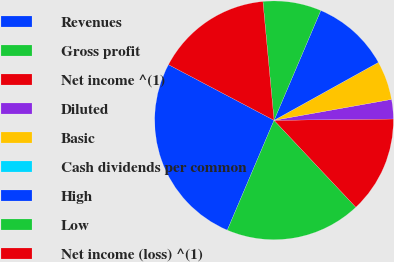<chart> <loc_0><loc_0><loc_500><loc_500><pie_chart><fcel>Revenues<fcel>Gross profit<fcel>Net income ^(1)<fcel>Diluted<fcel>Basic<fcel>Cash dividends per common<fcel>High<fcel>Low<fcel>Net income (loss) ^(1)<nl><fcel>26.32%<fcel>18.42%<fcel>13.16%<fcel>2.63%<fcel>5.26%<fcel>0.0%<fcel>10.53%<fcel>7.89%<fcel>15.79%<nl></chart> 